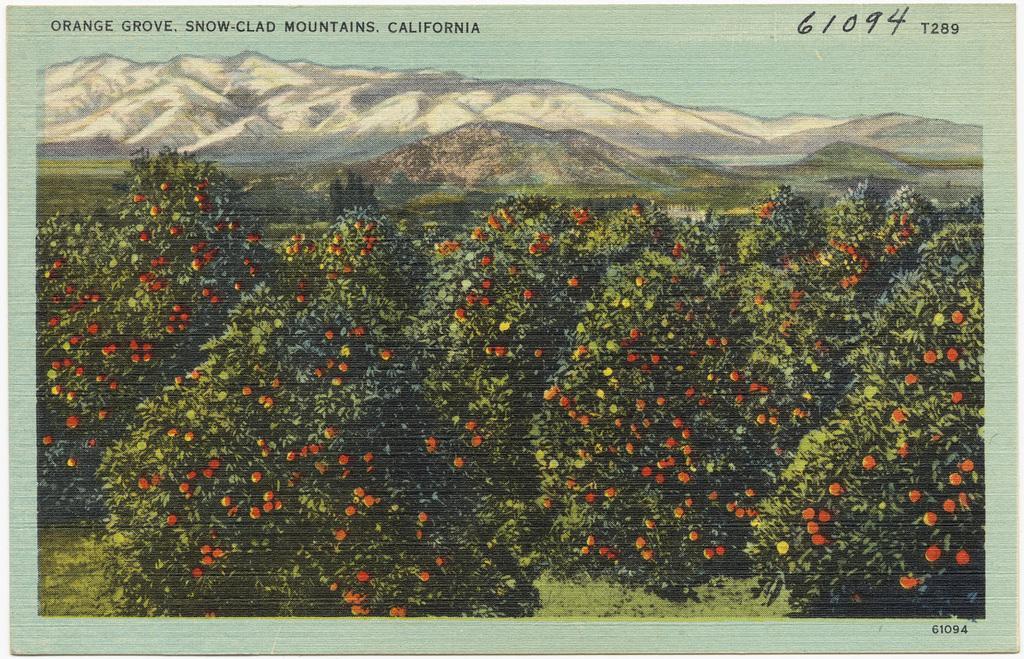Could you give a brief overview of what you see in this image? In this image there is a frame, there is the sky, there are mountains, there are trees, there are fruits, there is grass, there is text on the image. 